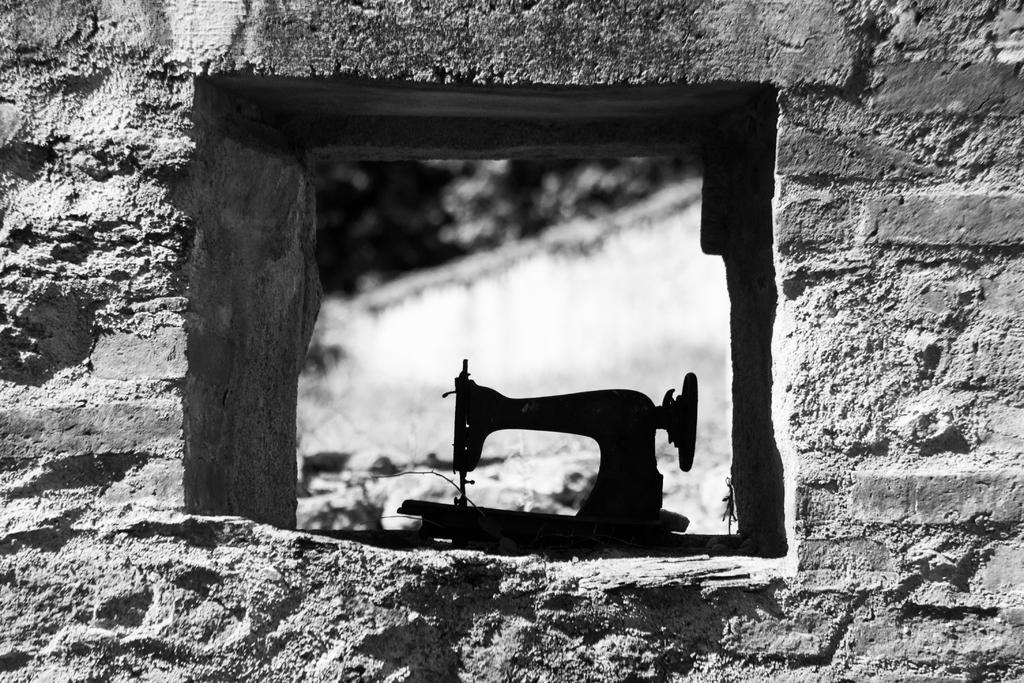Could you give a brief overview of what you see in this image? In this picture we can see the wall, sewing machine and in the background it is blurry. 